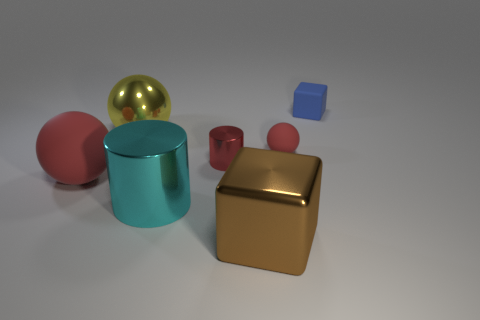Add 2 large yellow matte cubes. How many objects exist? 9 Subtract all metallic spheres. How many spheres are left? 2 Subtract all yellow balls. How many balls are left? 2 Subtract all balls. How many objects are left? 4 Subtract 1 cylinders. How many cylinders are left? 1 Subtract all gray blocks. Subtract all red cylinders. How many blocks are left? 2 Subtract all red spheres. How many green cubes are left? 0 Subtract all brown metal cubes. Subtract all brown objects. How many objects are left? 5 Add 5 shiny cubes. How many shiny cubes are left? 6 Add 2 small red balls. How many small red balls exist? 3 